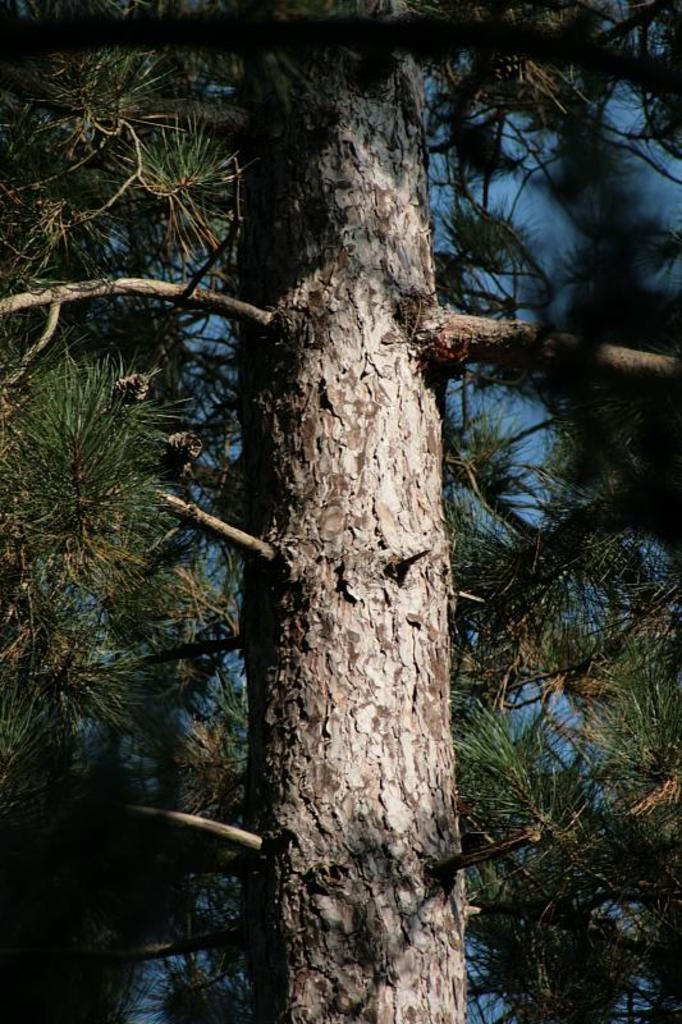What type of natural element can be seen in the image? There is a tree in the image. What is visible in the background of the image? The sky is visible in the background of the image. What color is present on the right side of the image? There is a black color on the right side of the image. Where is another instance of black color in the image? There is a black color in the left corner of the image. Can you see a rabbit hiding behind the tree in the image? There is no rabbit present in the image; only a tree and the sky are visible. 